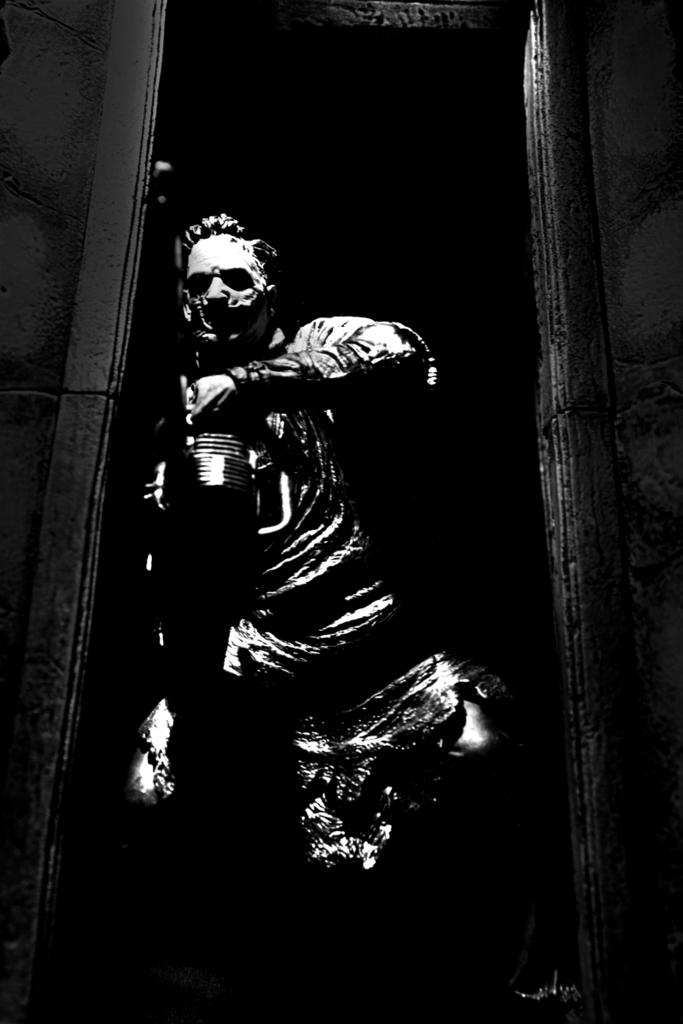What is the main subject in the center of the image? There is a statue in the center of the image. What can be seen on the right side of the image? There is a door on the right side of the image. What type of toothpaste is the robin using in the image? There is no robin or toothpaste present in the image. 